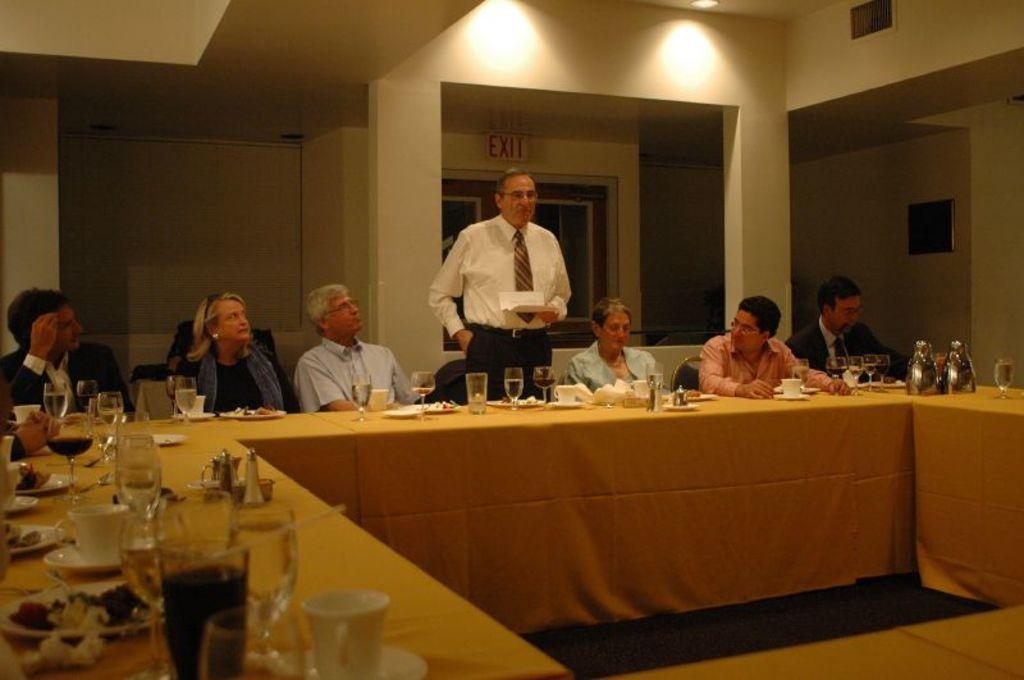Can you describe this image briefly? In the given image we can see that, this man is standing and the rest are sitting. This is a table on which wine glass, tea cup and food in plate are kept. 